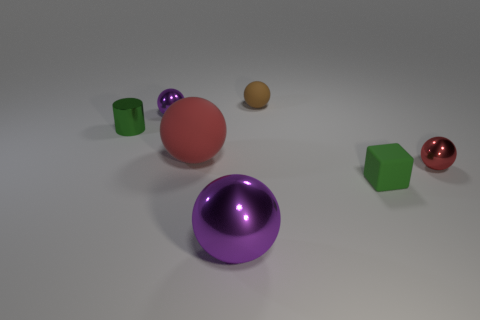Subtract all small brown matte balls. How many balls are left? 4 Add 2 small brown rubber spheres. How many objects exist? 9 Subtract all red balls. How many balls are left? 3 Subtract 1 cylinders. How many cylinders are left? 0 Subtract all yellow cylinders. How many brown balls are left? 1 Add 4 tiny matte blocks. How many tiny matte blocks exist? 5 Subtract 0 yellow cylinders. How many objects are left? 7 Subtract all cylinders. How many objects are left? 6 Subtract all gray cylinders. Subtract all red blocks. How many cylinders are left? 1 Subtract all large yellow metal cubes. Subtract all red balls. How many objects are left? 5 